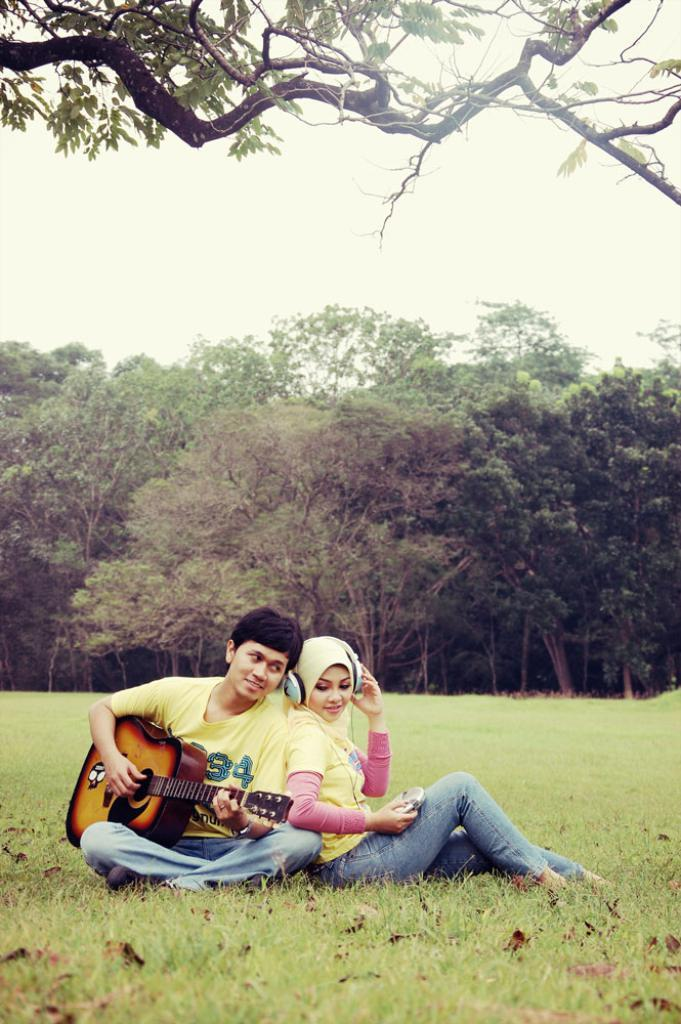How many people are in the image? There are two persons in the image. What are the two persons doing in the image? The two persons are sitting on the ground and playing a musical instrument. What can be seen in the background of the image? There is a sky and a tree visible in the background of the image. What type of page is being turned by the wind in the image? There is no page or wind present in the image; it features two persons playing a musical instrument. What is the current status of the box in the image? There is no box present in the image. 